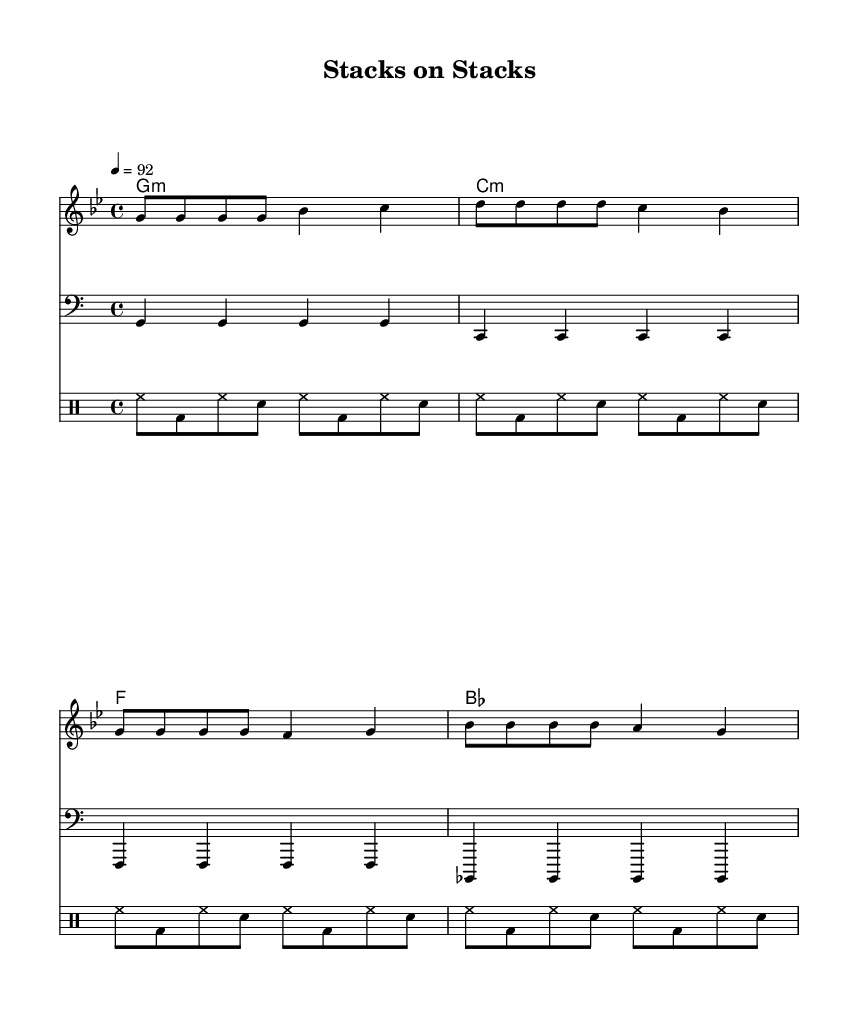What is the key signature of this music? The key signature is G minor, which has two flats (B flat and E flat). You can identify it by looking at the key signature symbol at the beginning of the staff, which indicates the notes that are altered throughout the piece.
Answer: G minor What is the time signature of this music? The time signature is 4/4, as indicated at the beginning of the piece. This means there are four beats in each measure and the quarter note gets one beat, which can typically be found just after the clef sign.
Answer: 4/4 What is the tempo marking of this piece? The tempo marking is a quarter note equals 92, which is indicated in the tempo section at the start. This provides the speed of the music. By looking closely at the tempo notation, you can see how fast the piece should be played.
Answer: 92 How many measures are there in the melody? There are four measures in the melody, as indicated by the division of the notes into distinct groupings within the 4/4 time signature throughout the staff. Each measure is counted starting from the beginning to the end of the melody block.
Answer: 4 What is the first lyric line of the song? The first lyric line of the song is "Stacks on stacks, that's all I see." You can see this clearly corresponding to the melody notation and the placement of the words under the notes they are sung on.
Answer: Stacks on stacks, that's all I see What is the underlying chord progression for this piece? The underlying chord progression is G minor, C minor, F major, and B flat major, which is indicated in the chord names above the staff. This can be seen in the chord names that correspond to the measured sections of the melody.
Answer: G minor, C minor, F, B flat 